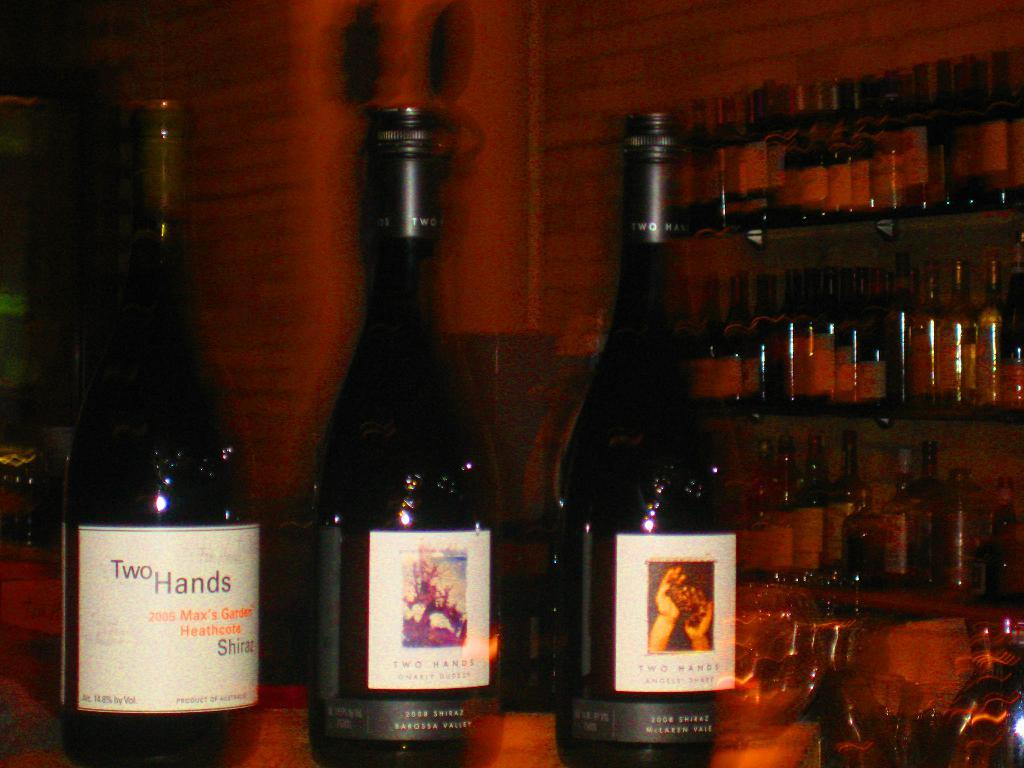<image>
Create a compact narrative representing the image presented. Three different bottle of Two Hands wine sitting on a bar. 